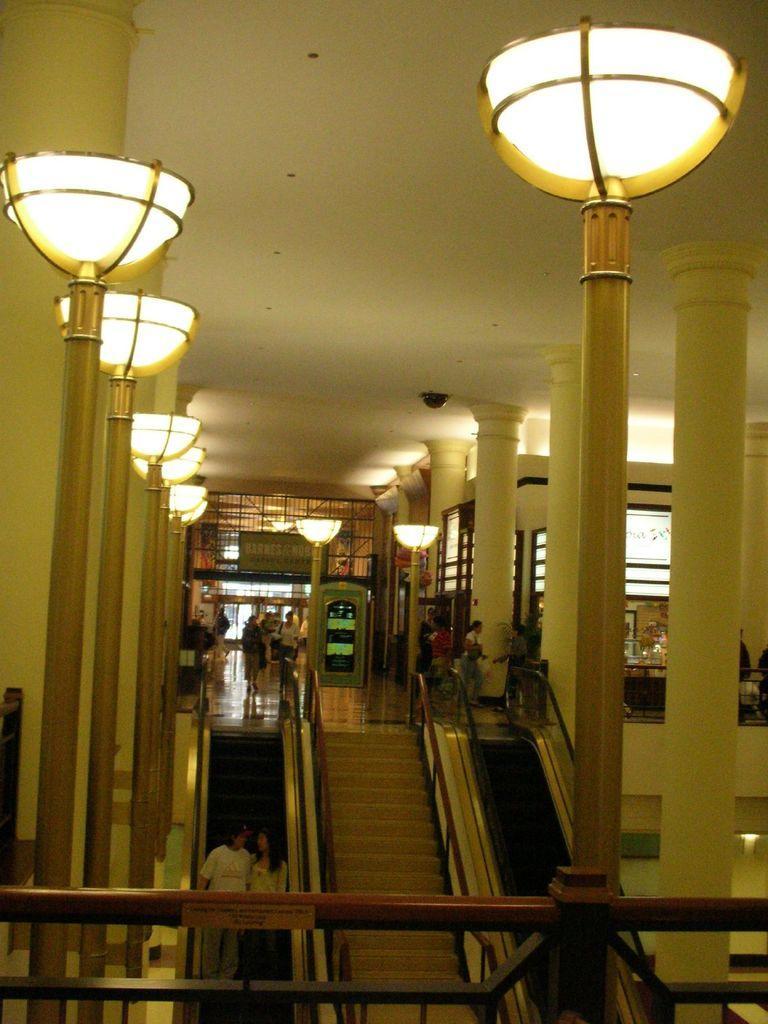Please provide a concise description of this image. In this image I can see two people on the stairs. These people are wearing the white color dresses. To the side there are few more stairs and I can see few people wearing different color dresses. There are lights to the side. I can see the railing. And there is a board can be seen. These are inside the building. 